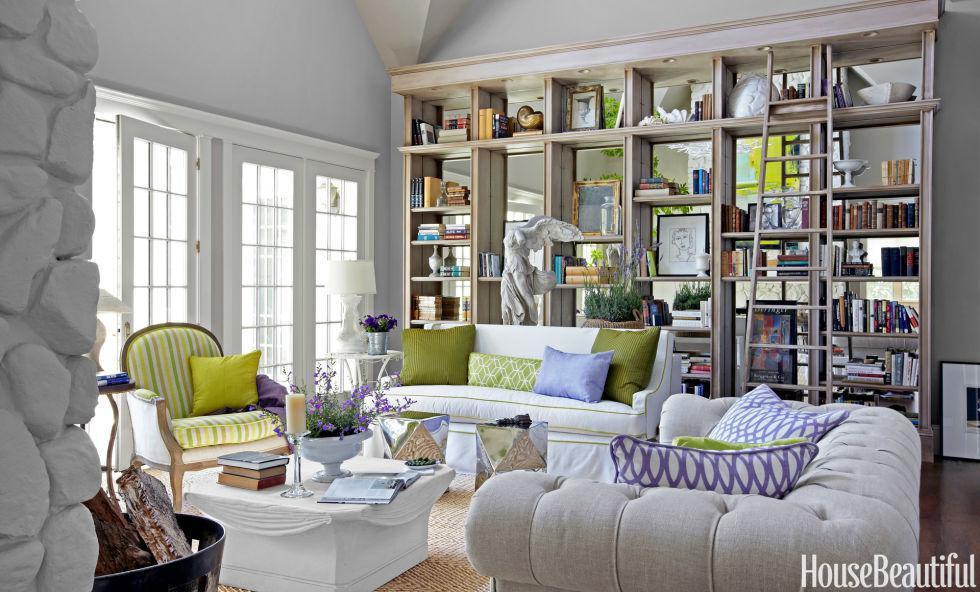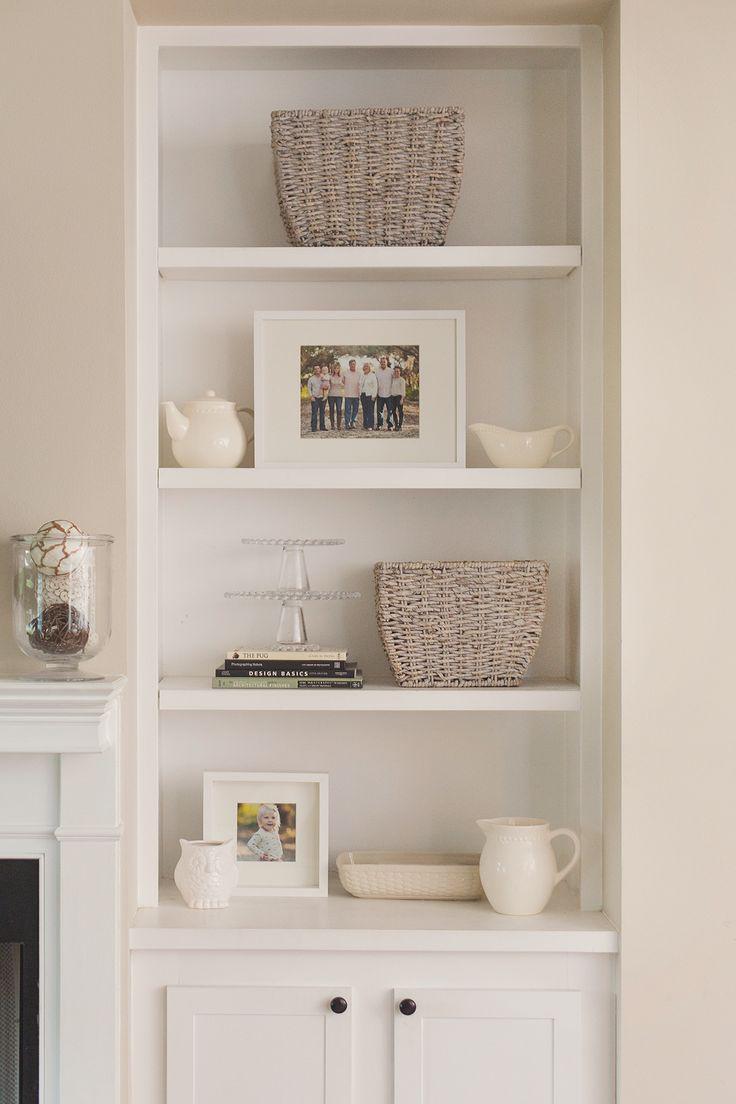The first image is the image on the left, the second image is the image on the right. For the images displayed, is the sentence "A room image features seating furniture on the right and a bookcase with at least 8 shelves." factually correct? Answer yes or no. Yes. 